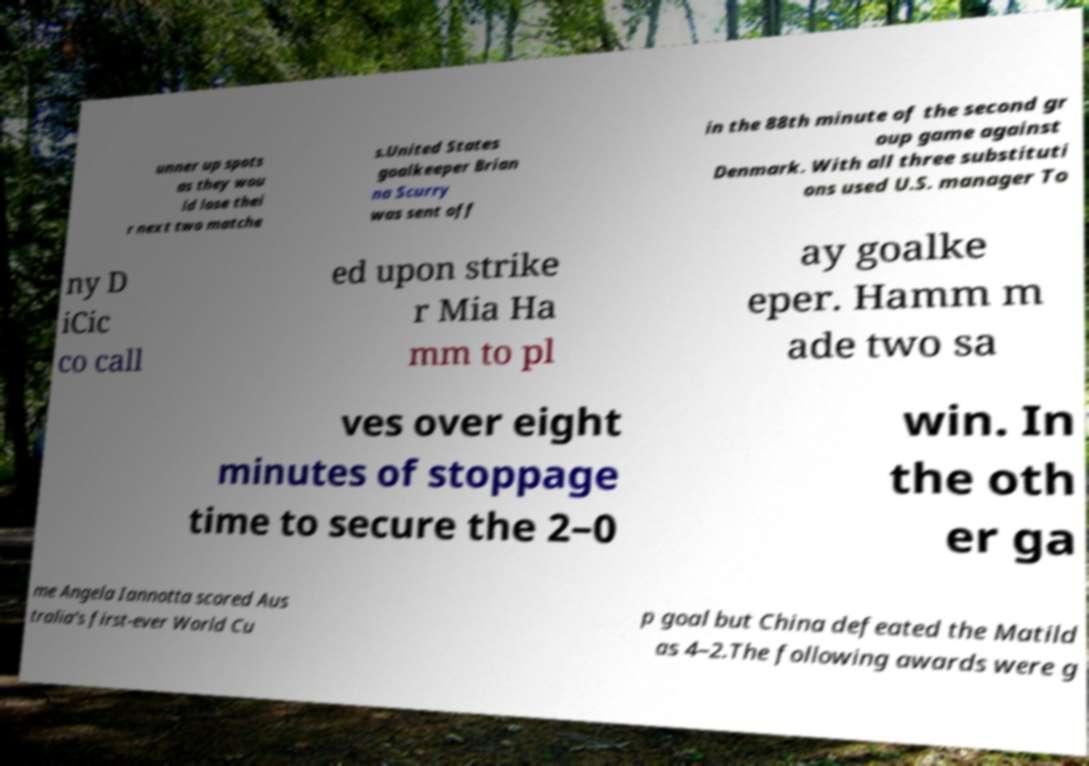Please identify and transcribe the text found in this image. unner up spots as they wou ld lose thei r next two matche s.United States goalkeeper Brian na Scurry was sent off in the 88th minute of the second gr oup game against Denmark. With all three substituti ons used U.S. manager To ny D iCic co call ed upon strike r Mia Ha mm to pl ay goalke eper. Hamm m ade two sa ves over eight minutes of stoppage time to secure the 2–0 win. In the oth er ga me Angela Iannotta scored Aus tralia's first-ever World Cu p goal but China defeated the Matild as 4–2.The following awards were g 